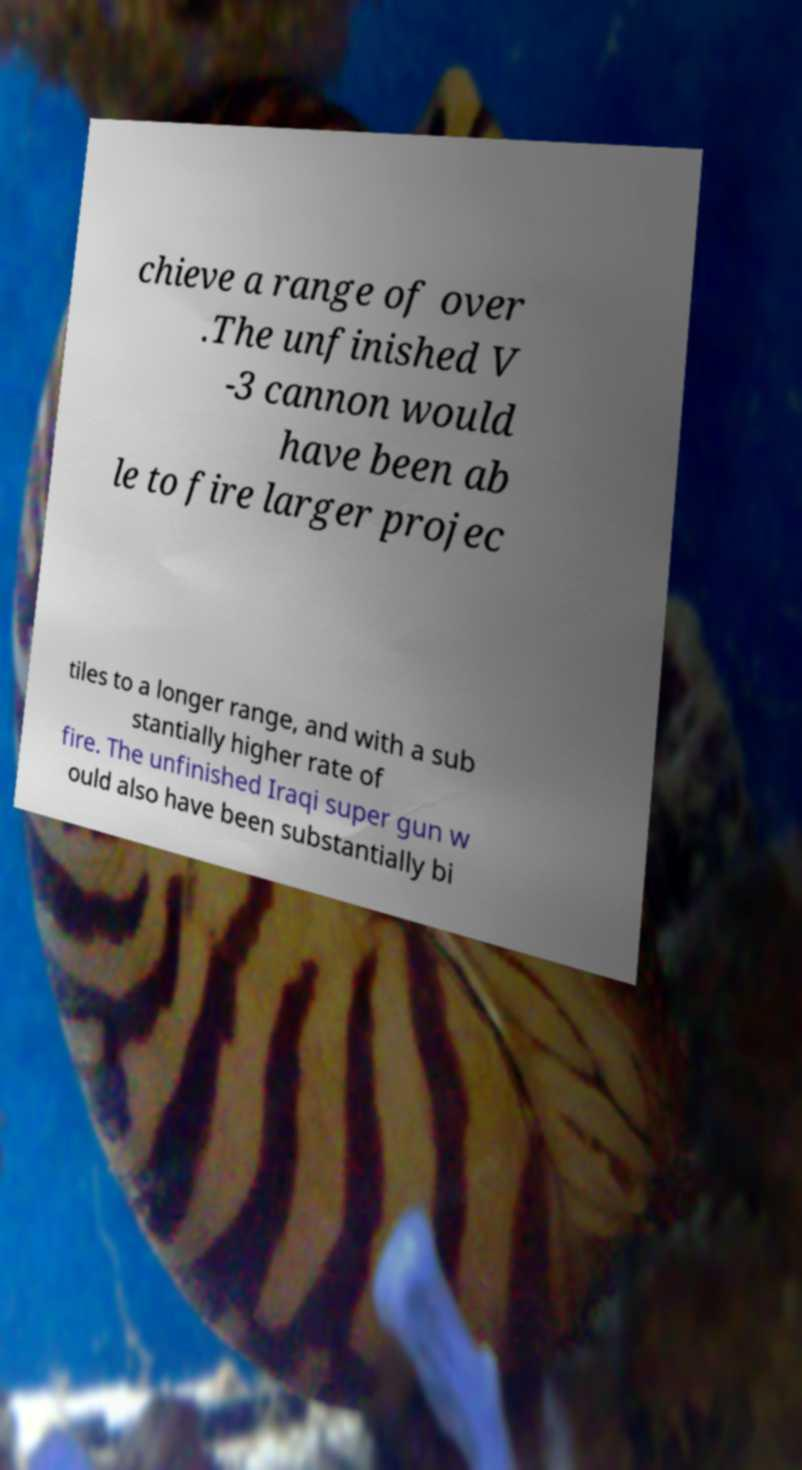Could you extract and type out the text from this image? chieve a range of over .The unfinished V -3 cannon would have been ab le to fire larger projec tiles to a longer range, and with a sub stantially higher rate of fire. The unfinished Iraqi super gun w ould also have been substantially bi 